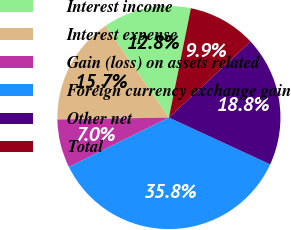Convert chart to OTSL. <chart><loc_0><loc_0><loc_500><loc_500><pie_chart><fcel>Interest income<fcel>Interest expense<fcel>Gain (loss) on assets related<fcel>Foreign currency exchange gain<fcel>Other net<fcel>Total<nl><fcel>12.78%<fcel>15.66%<fcel>7.02%<fcel>35.82%<fcel>18.83%<fcel>9.9%<nl></chart> 